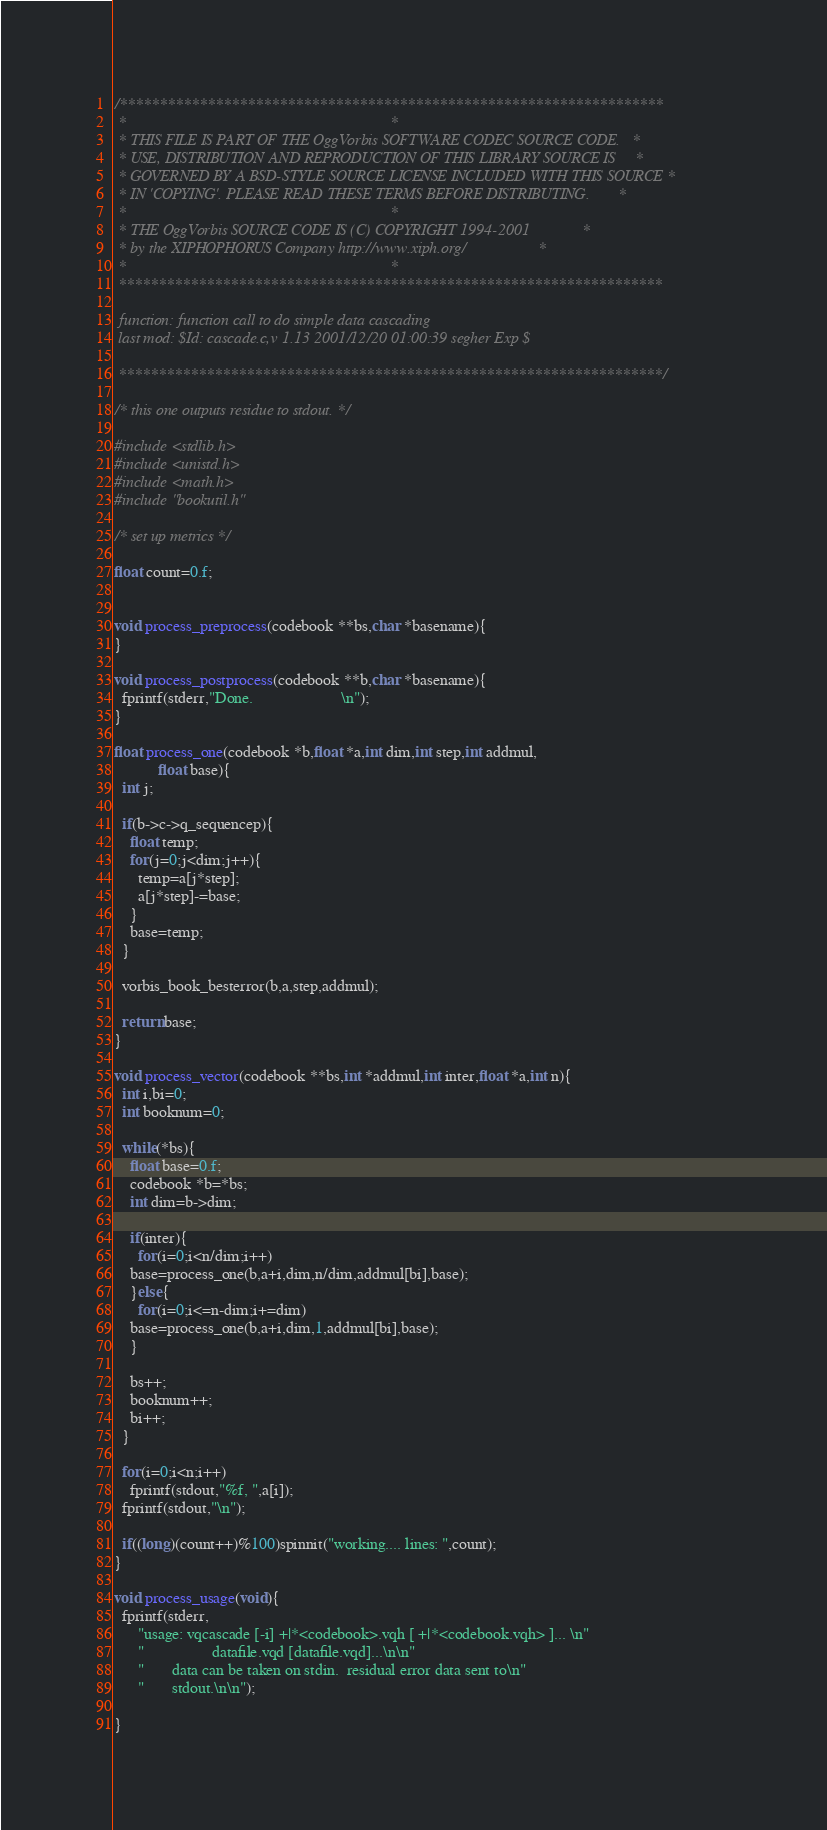<code> <loc_0><loc_0><loc_500><loc_500><_C_>/********************************************************************
 *                                                                  *
 * THIS FILE IS PART OF THE OggVorbis SOFTWARE CODEC SOURCE CODE.   *
 * USE, DISTRIBUTION AND REPRODUCTION OF THIS LIBRARY SOURCE IS     *
 * GOVERNED BY A BSD-STYLE SOURCE LICENSE INCLUDED WITH THIS SOURCE *
 * IN 'COPYING'. PLEASE READ THESE TERMS BEFORE DISTRIBUTING.       *
 *                                                                  *
 * THE OggVorbis SOURCE CODE IS (C) COPYRIGHT 1994-2001             *
 * by the XIPHOPHORUS Company http://www.xiph.org/                  *
 *                                                                  *
 ********************************************************************

 function: function call to do simple data cascading
 last mod: $Id: cascade.c,v 1.13 2001/12/20 01:00:39 segher Exp $

 ********************************************************************/

/* this one outputs residue to stdout. */

#include <stdlib.h>
#include <unistd.h>
#include <math.h>
#include "bookutil.h"

/* set up metrics */

float count=0.f;


void process_preprocess(codebook **bs,char *basename){
}

void process_postprocess(codebook **b,char *basename){
  fprintf(stderr,"Done.                      \n");
}

float process_one(codebook *b,float *a,int dim,int step,int addmul,
		   float base){
  int j;

  if(b->c->q_sequencep){
    float temp;
    for(j=0;j<dim;j++){
      temp=a[j*step];
      a[j*step]-=base;
    }
    base=temp;
  }

  vorbis_book_besterror(b,a,step,addmul);
  
  return base;
}

void process_vector(codebook **bs,int *addmul,int inter,float *a,int n){
  int i,bi=0;
  int booknum=0;
  
  while(*bs){
    float base=0.f;
    codebook *b=*bs;
    int dim=b->dim;
    
    if(inter){
      for(i=0;i<n/dim;i++)
	base=process_one(b,a+i,dim,n/dim,addmul[bi],base);
    }else{
      for(i=0;i<=n-dim;i+=dim)
	base=process_one(b,a+i,dim,1,addmul[bi],base);
    }

    bs++;
    booknum++;
    bi++;
  }

  for(i=0;i<n;i++)
    fprintf(stdout,"%f, ",a[i]);
  fprintf(stdout,"\n");
  
  if((long)(count++)%100)spinnit("working.... lines: ",count);
}

void process_usage(void){
  fprintf(stderr,
	  "usage: vqcascade [-i] +|*<codebook>.vqh [ +|*<codebook.vqh> ]... \n"
	  "                 datafile.vqd [datafile.vqd]...\n\n"
	  "       data can be taken on stdin.  residual error data sent to\n"
	  "       stdout.\n\n");

}
</code> 